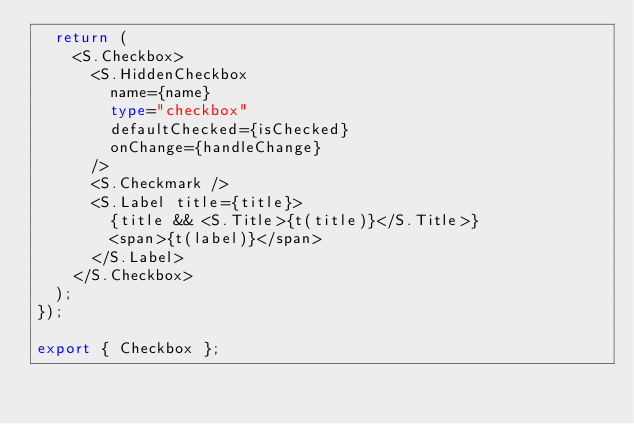Convert code to text. <code><loc_0><loc_0><loc_500><loc_500><_TypeScript_>  return (
    <S.Checkbox>
      <S.HiddenCheckbox
        name={name}
        type="checkbox"
        defaultChecked={isChecked}
        onChange={handleChange}
      />
      <S.Checkmark />
      <S.Label title={title}>
        {title && <S.Title>{t(title)}</S.Title>}
        <span>{t(label)}</span>
      </S.Label>
    </S.Checkbox>
  );
});

export { Checkbox };
</code> 